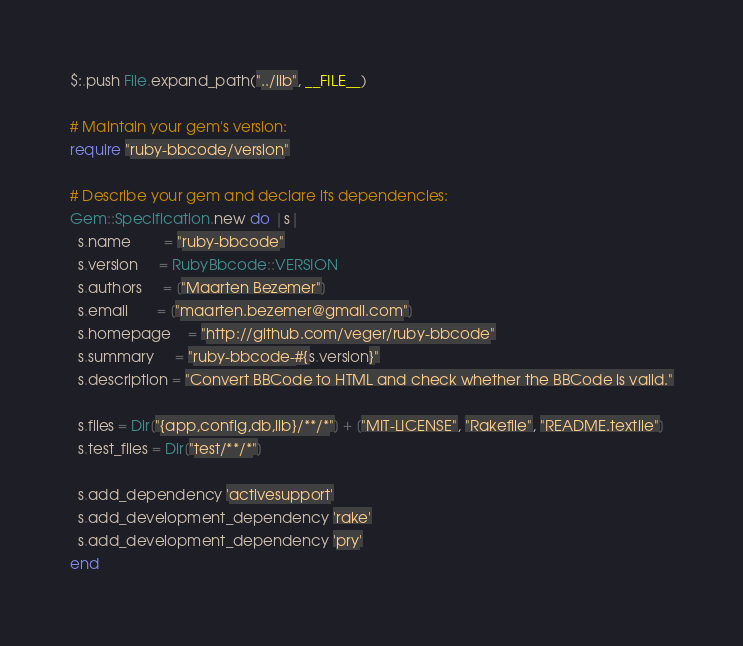Convert code to text. <code><loc_0><loc_0><loc_500><loc_500><_Ruby_>$:.push File.expand_path("../lib", __FILE__)

# Maintain your gem's version:
require "ruby-bbcode/version"

# Describe your gem and declare its dependencies:
Gem::Specification.new do |s|
  s.name        = "ruby-bbcode"
  s.version     = RubyBbcode::VERSION
  s.authors     = ["Maarten Bezemer"]
  s.email       = ["maarten.bezemer@gmail.com"]
  s.homepage    = "http://github.com/veger/ruby-bbcode"
  s.summary     = "ruby-bbcode-#{s.version}"
  s.description = "Convert BBCode to HTML and check whether the BBCode is valid."

  s.files = Dir["{app,config,db,lib}/**/*"] + ["MIT-LICENSE", "Rakefile", "README.textile"]
  s.test_files = Dir["test/**/*"]
  
  s.add_dependency 'activesupport'
  s.add_development_dependency 'rake'
  s.add_development_dependency 'pry'
end
</code> 